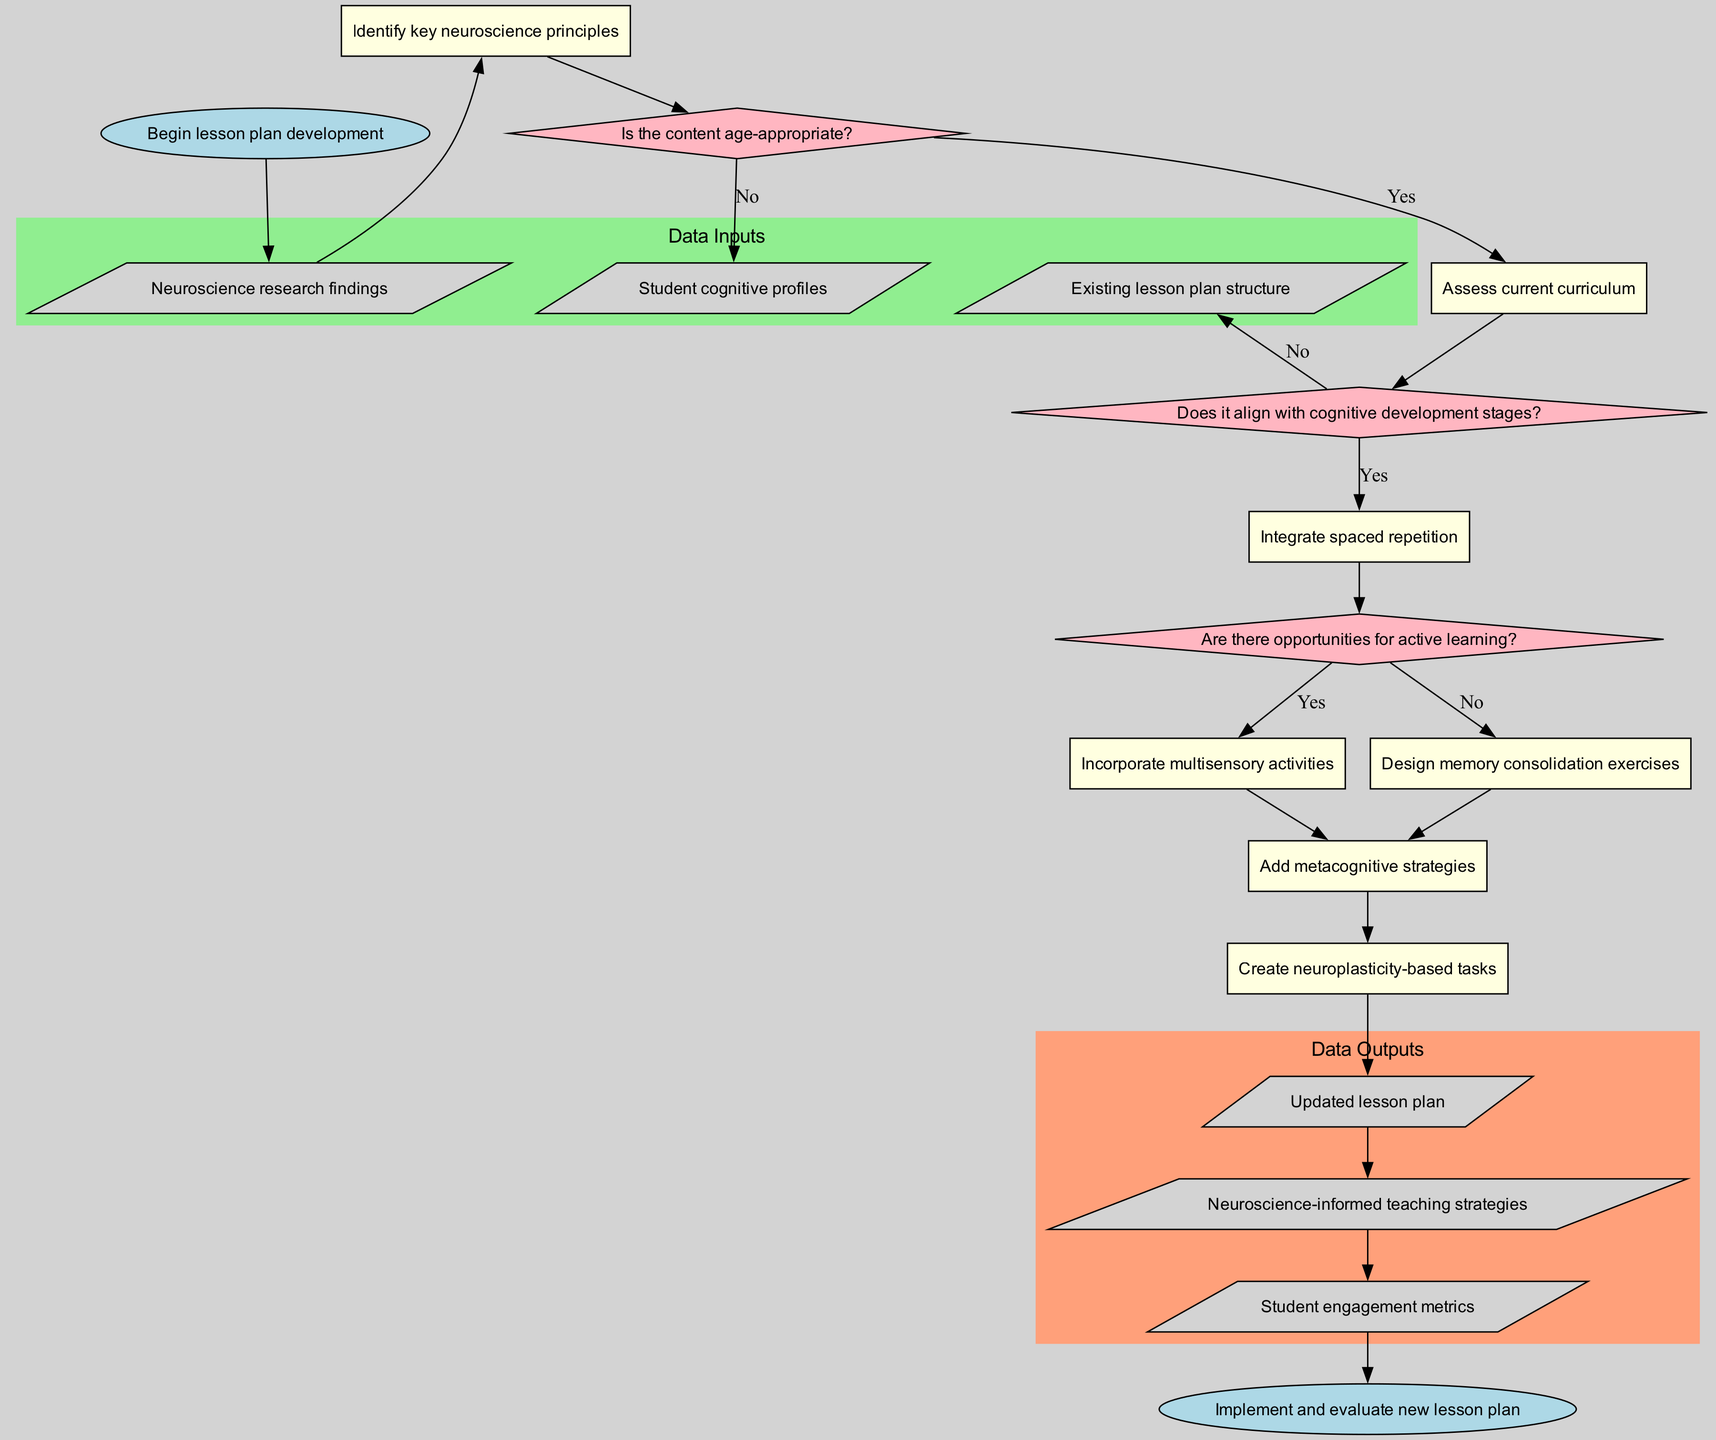What is the starting node of the flowchart? The starting node is explicitly labeled in the diagram as "Begin lesson plan development." This node initiates the process, which is clearly marked at the top.
Answer: Begin lesson plan development How many decision nodes are present in the diagram? The diagram contains three decision nodes, which evaluate the conditions regarding age-appropriateness, cognitive development alignment, and opportunities for active learning. These nodes are represented by diamond shapes.
Answer: 3 What is the output of the final process in the flowchart? The final process leads to the output labeled "Neuroscience-informed teaching strategies." This indicates the outcome of integrating neuroscience principles into lesson plans.
Answer: Neuroscience-informed teaching strategies What happens if the content is not age-appropriate? If the content is not age-appropriate, the flow indicates moving to the next input, which is "Student cognitive profiles." This shows the decision-making process and how it leads to reassessing the content.
Answer: Student cognitive profiles What are the data inputs utilized in this diagram? The diagram specifies three data inputs: "Neuroscience research findings," "Student cognitive profiles," and "Existing lesson plan structure." These inputs feed into the subsequent processes.
Answer: Neuroscience research findings, Student cognitive profiles, Existing lesson plan structure What process follows after acknowledging that there are opportunities for active learning? Once it is confirmed that there are opportunities for active learning, the flow directs to the process labeled "Integrate spaced repetition." This step emphasizes incorporating techniques found effective in neuroscience for better learning retention.
Answer: Integrate spaced repetition If the first process is executed, what is the next decision node? After the first process, which is "Identify key neuroscience principles," the next decision node is "Does it align with cognitive development stages?" This continues the assessment of the content's suitability.
Answer: Does it align with cognitive development stages? What color is used for the end node in this flowchart? The end node is colored light blue, similar to the start node, and is labeled "Implement and evaluate new lesson plan," indicating the conclusion of the flowchart process.
Answer: light blue 